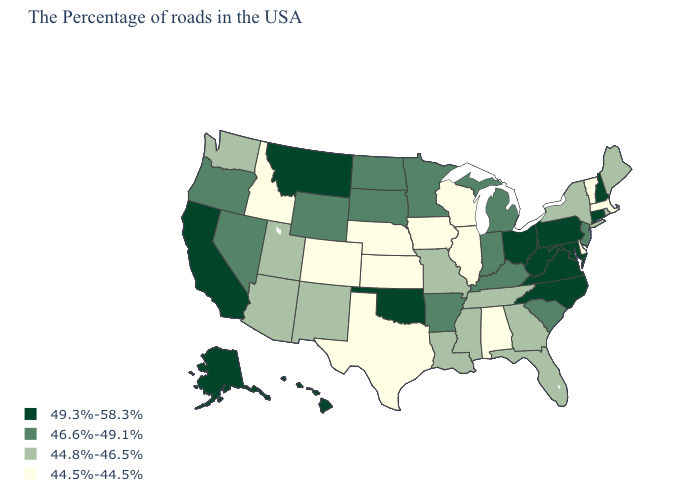What is the value of Rhode Island?
Answer briefly. 44.8%-46.5%. What is the value of Indiana?
Be succinct. 46.6%-49.1%. What is the lowest value in the MidWest?
Write a very short answer. 44.5%-44.5%. Among the states that border Kansas , which have the lowest value?
Answer briefly. Nebraska, Colorado. What is the value of Florida?
Concise answer only. 44.8%-46.5%. Name the states that have a value in the range 46.6%-49.1%?
Be succinct. New Jersey, South Carolina, Michigan, Kentucky, Indiana, Arkansas, Minnesota, South Dakota, North Dakota, Wyoming, Nevada, Oregon. What is the value of Utah?
Quick response, please. 44.8%-46.5%. Name the states that have a value in the range 44.5%-44.5%?
Short answer required. Massachusetts, Vermont, Delaware, Alabama, Wisconsin, Illinois, Iowa, Kansas, Nebraska, Texas, Colorado, Idaho. What is the highest value in states that border Rhode Island?
Concise answer only. 49.3%-58.3%. What is the value of California?
Write a very short answer. 49.3%-58.3%. What is the value of Kansas?
Short answer required. 44.5%-44.5%. Does the first symbol in the legend represent the smallest category?
Keep it brief. No. What is the value of Georgia?
Quick response, please. 44.8%-46.5%. What is the value of Arkansas?
Be succinct. 46.6%-49.1%. Which states have the lowest value in the USA?
Short answer required. Massachusetts, Vermont, Delaware, Alabama, Wisconsin, Illinois, Iowa, Kansas, Nebraska, Texas, Colorado, Idaho. 